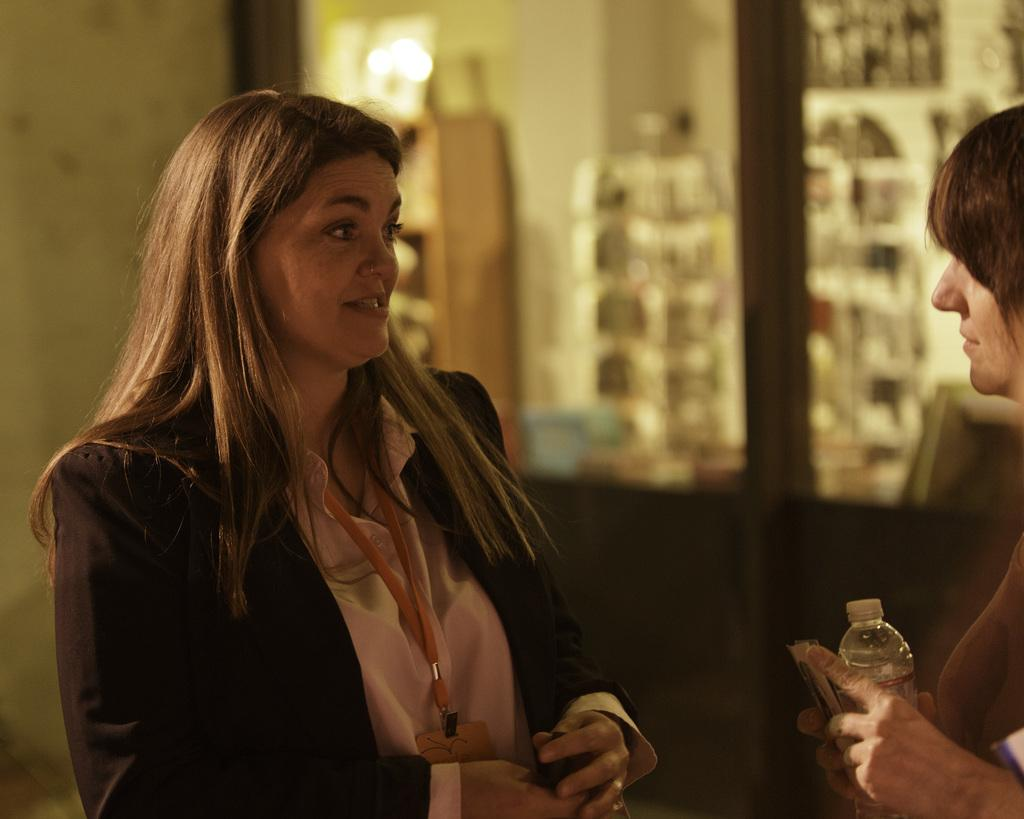How many women are present in the image? There are two women in the image. What are the women doing in the image? One woman is standing on the left side, and the other woman is holding a bottle on the right side. What can be seen in the background of the image? There is a yellow color wall in the background of the image. What type of discovery did the writer make in the image? There is no writer or discovery present in the image. What is the base of the bottle that the woman is holding? The image does not provide enough detail to determine the base of the bottle. 